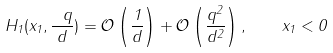<formula> <loc_0><loc_0><loc_500><loc_500>H _ { 1 } ( x _ { 1 } , \frac { \ q } { d } ) = \mathcal { O } \left ( \frac { 1 } { d } \right ) + \mathcal { O } \left ( \frac { q ^ { 2 } } { d ^ { 2 } } \right ) , \quad x _ { 1 } < 0</formula> 